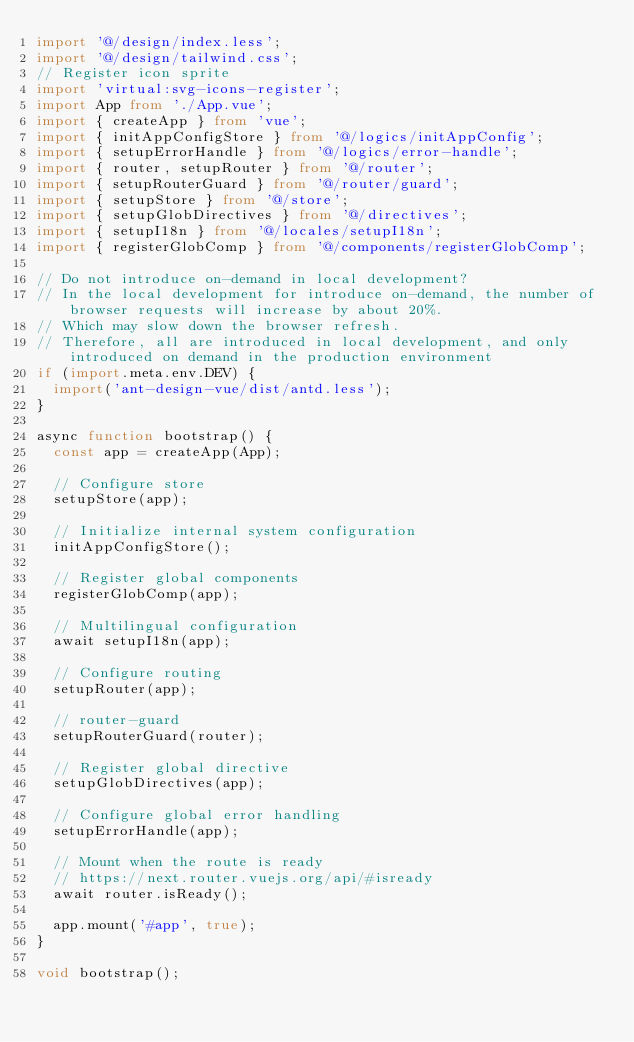Convert code to text. <code><loc_0><loc_0><loc_500><loc_500><_TypeScript_>import '@/design/index.less';
import '@/design/tailwind.css';
// Register icon sprite
import 'virtual:svg-icons-register';
import App from './App.vue';
import { createApp } from 'vue';
import { initAppConfigStore } from '@/logics/initAppConfig';
import { setupErrorHandle } from '@/logics/error-handle';
import { router, setupRouter } from '@/router';
import { setupRouterGuard } from '@/router/guard';
import { setupStore } from '@/store';
import { setupGlobDirectives } from '@/directives';
import { setupI18n } from '@/locales/setupI18n';
import { registerGlobComp } from '@/components/registerGlobComp';

// Do not introduce on-demand in local development?
// In the local development for introduce on-demand, the number of browser requests will increase by about 20%.
// Which may slow down the browser refresh.
// Therefore, all are introduced in local development, and only introduced on demand in the production environment
if (import.meta.env.DEV) {
  import('ant-design-vue/dist/antd.less');
}

async function bootstrap() {
  const app = createApp(App);

  // Configure store
  setupStore(app);

  // Initialize internal system configuration
  initAppConfigStore();

  // Register global components
  registerGlobComp(app);

  // Multilingual configuration
  await setupI18n(app);

  // Configure routing
  setupRouter(app);

  // router-guard
  setupRouterGuard(router);

  // Register global directive
  setupGlobDirectives(app);

  // Configure global error handling
  setupErrorHandle(app);

  // Mount when the route is ready
  // https://next.router.vuejs.org/api/#isready
  await router.isReady();

  app.mount('#app', true);
}

void bootstrap();
</code> 